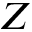<formula> <loc_0><loc_0><loc_500><loc_500>Z</formula> 